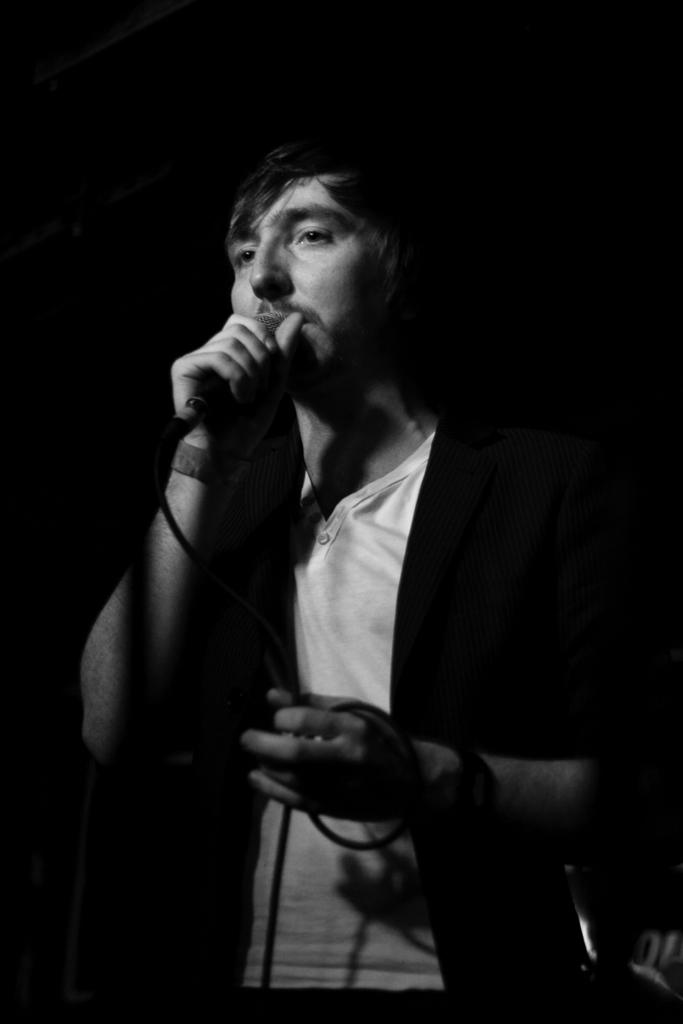What is the man in the image doing? The man is singing in the image. What object is the man holding while singing? The man is holding a microphone. How does the man untie the knot in the image? There is no knot present in the image, as the man is singing and holding a microphone. 